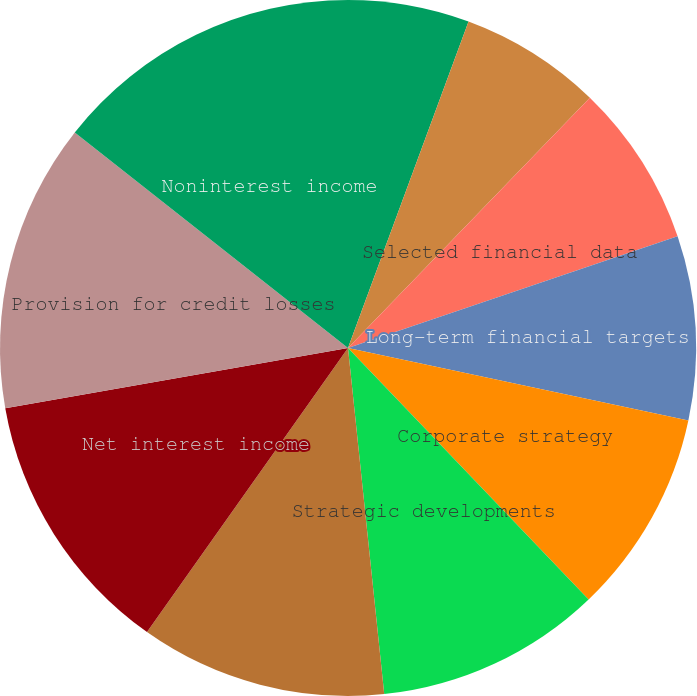Convert chart to OTSL. <chart><loc_0><loc_0><loc_500><loc_500><pie_chart><fcel>Introduction<fcel>Terminology<fcel>Selected financial data<fcel>Long-term financial targets<fcel>Corporate strategy<fcel>Strategic developments<fcel>Results of Operations<fcel>Net interest income<fcel>Provision for credit losses<fcel>Noninterest income<nl><fcel>5.63%<fcel>6.6%<fcel>7.57%<fcel>8.54%<fcel>9.51%<fcel>10.49%<fcel>11.46%<fcel>12.43%<fcel>13.4%<fcel>14.37%<nl></chart> 